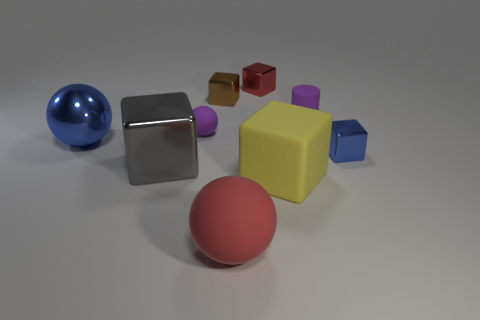Subtract all blue metallic blocks. How many blocks are left? 4 Subtract all brown cubes. How many cubes are left? 4 Subtract all yellow cubes. Subtract all cyan balls. How many cubes are left? 4 Add 1 small brown metal things. How many objects exist? 10 Subtract all cylinders. How many objects are left? 8 Subtract 1 gray blocks. How many objects are left? 8 Subtract all yellow blocks. Subtract all red rubber things. How many objects are left? 7 Add 3 large blue objects. How many large blue objects are left? 4 Add 2 gray shiny objects. How many gray shiny objects exist? 3 